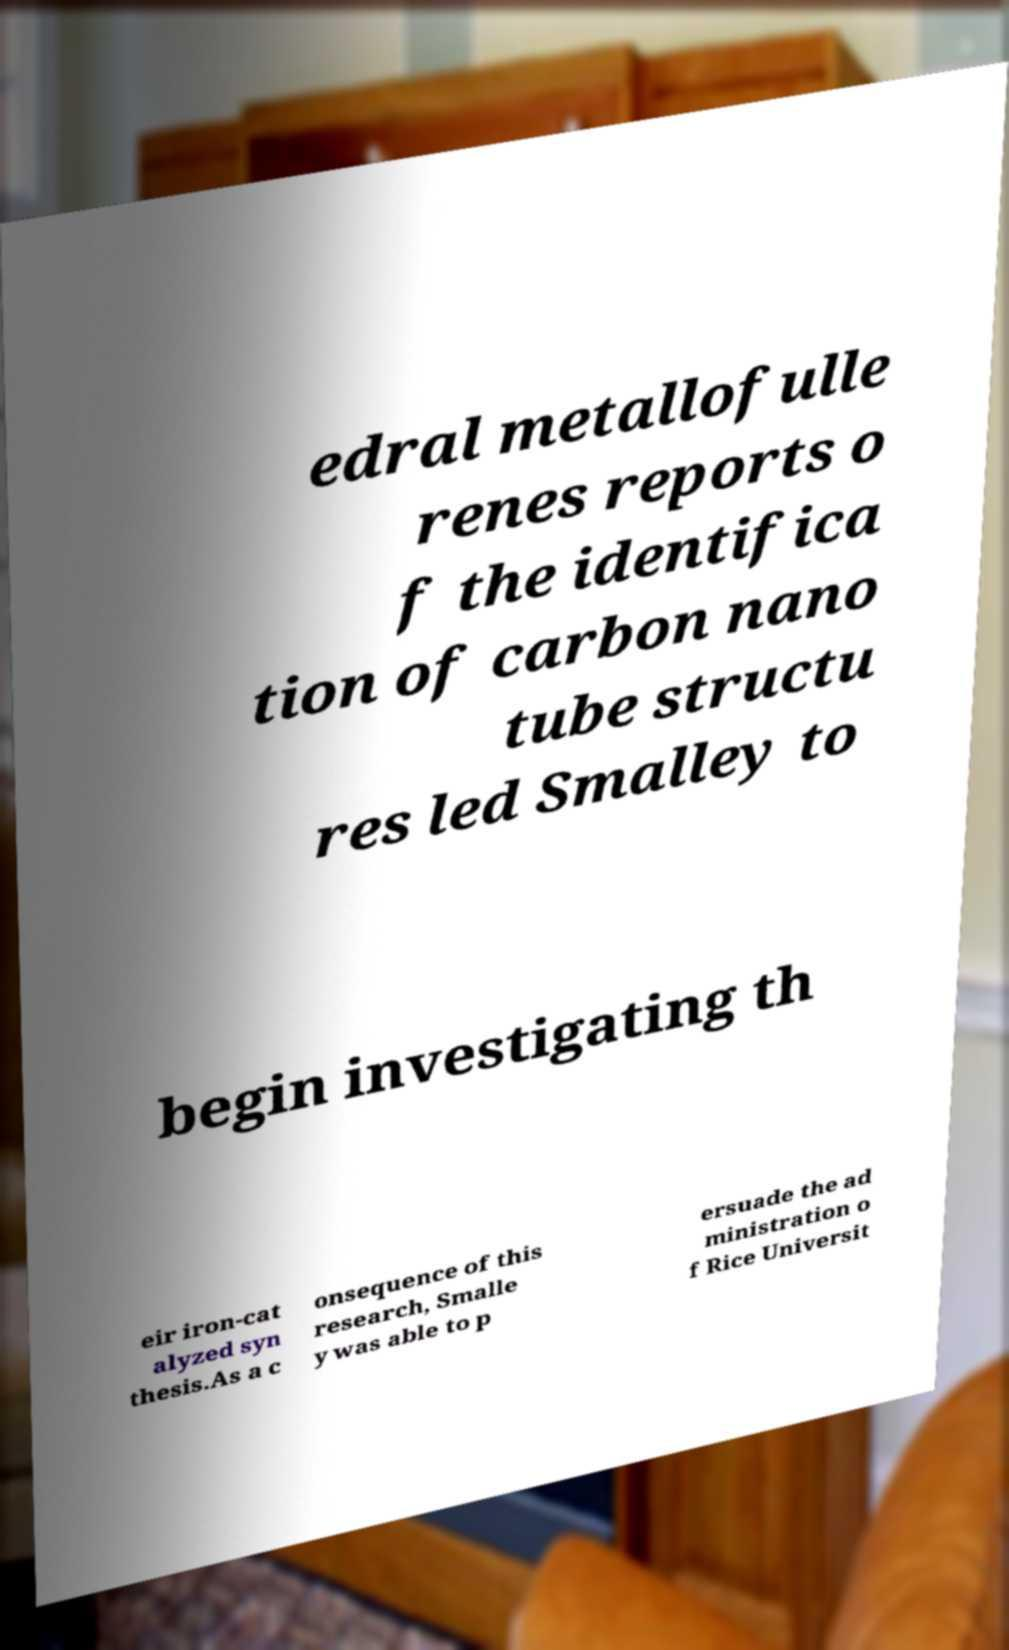There's text embedded in this image that I need extracted. Can you transcribe it verbatim? edral metallofulle renes reports o f the identifica tion of carbon nano tube structu res led Smalley to begin investigating th eir iron-cat alyzed syn thesis.As a c onsequence of this research, Smalle y was able to p ersuade the ad ministration o f Rice Universit 